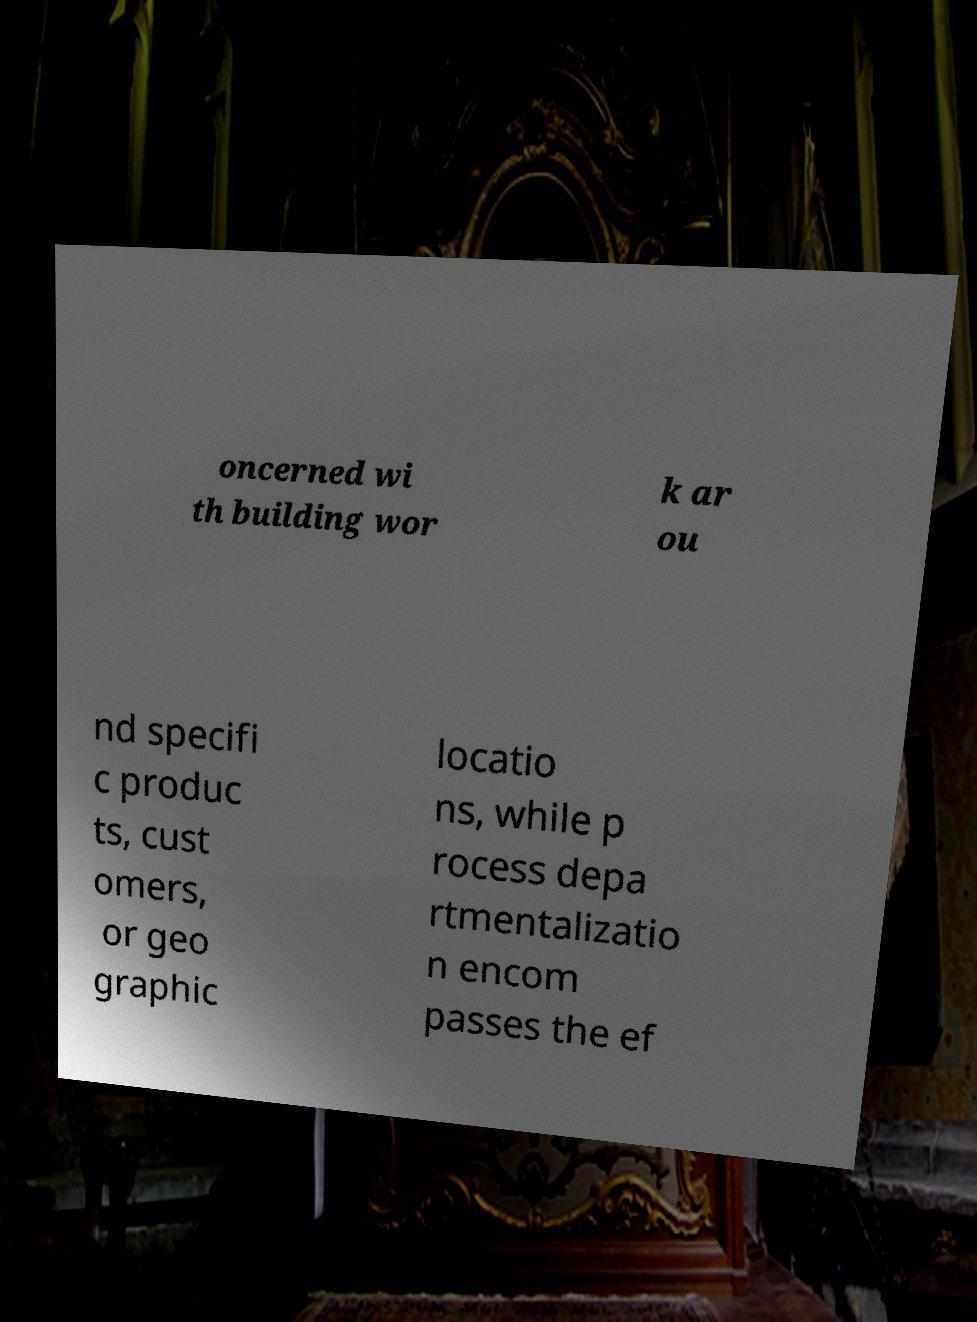Please read and relay the text visible in this image. What does it say? oncerned wi th building wor k ar ou nd specifi c produc ts, cust omers, or geo graphic locatio ns, while p rocess depa rtmentalizatio n encom passes the ef 